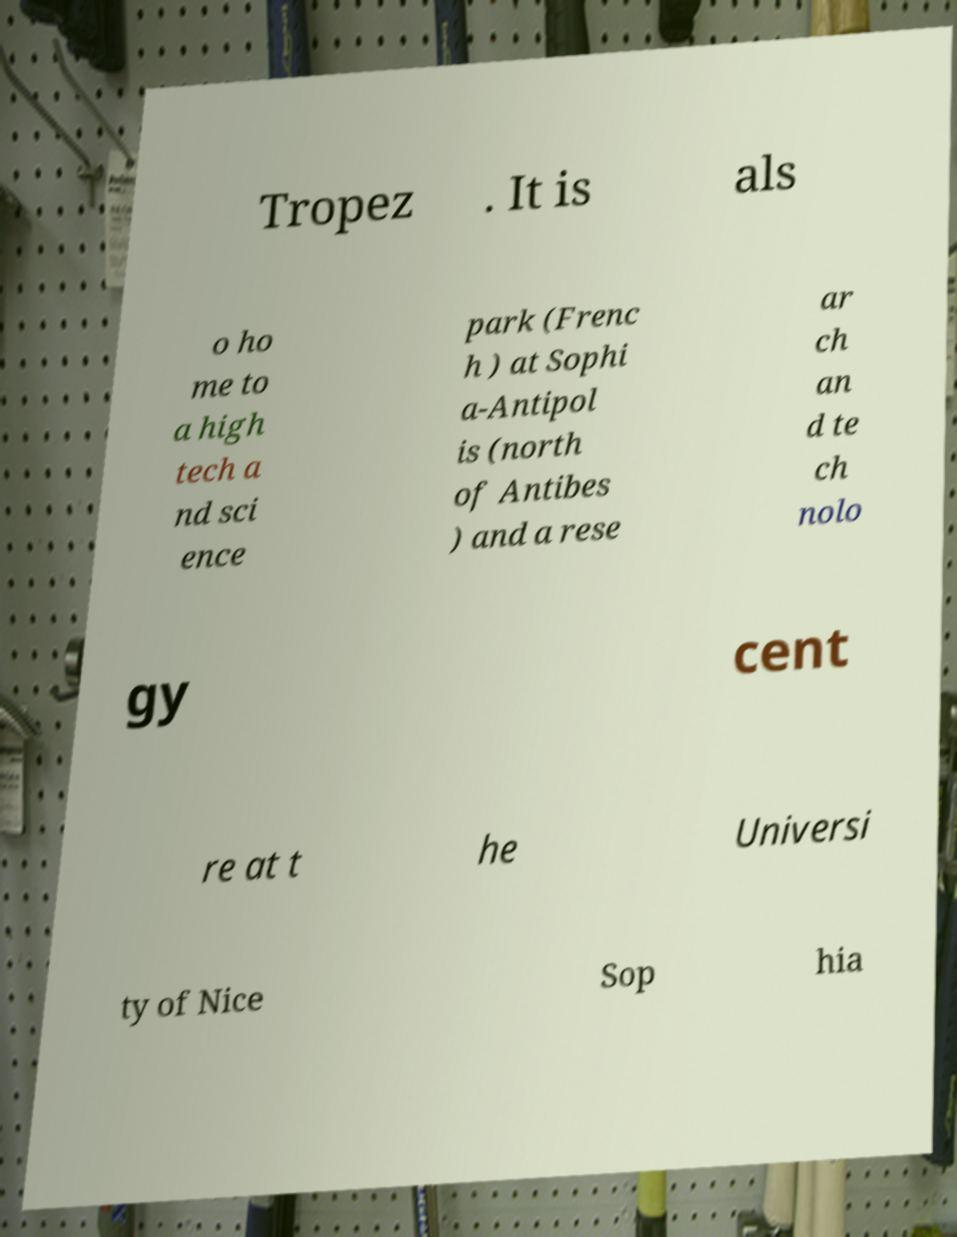I need the written content from this picture converted into text. Can you do that? Tropez . It is als o ho me to a high tech a nd sci ence park (Frenc h ) at Sophi a-Antipol is (north of Antibes ) and a rese ar ch an d te ch nolo gy cent re at t he Universi ty of Nice Sop hia 